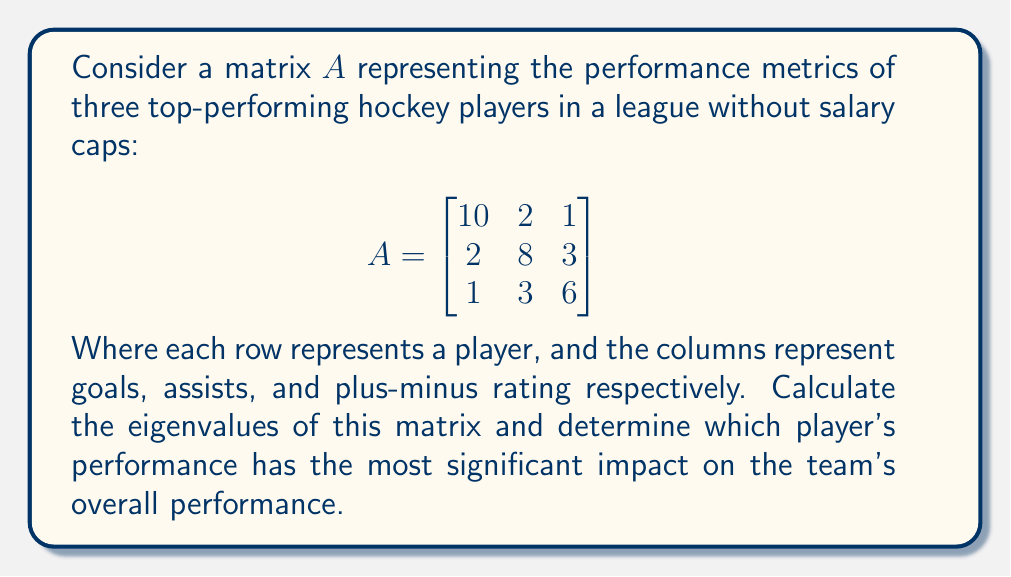What is the answer to this math problem? To find the eigenvalues of matrix $A$, we need to solve the characteristic equation:

$\det(A - \lambda I) = 0$

1) First, let's set up the matrix $A - \lambda I$:

$$A - \lambda I = \begin{bmatrix}
10-\lambda & 2 & 1 \\
2 & 8-\lambda & 3 \\
1 & 3 & 6-\lambda
\end{bmatrix}$$

2) Now, we calculate the determinant:

$\det(A - \lambda I) = (10-\lambda)[(8-\lambda)(6-\lambda) - 9] - 2[2(6-\lambda) - 3] + 1[2(3) - (8-\lambda)]$

3) Expanding this:

$\det(A - \lambda I) = (10-\lambda)(48-14\lambda+\lambda^2-9) - 2(12-2\lambda-3) + (6-8+\lambda)$
$= (10-\lambda)(39-14\lambda+\lambda^2) - 2(9-2\lambda) + (\lambda-2)$
$= 390 - 140\lambda + 10\lambda^2 - 39\lambda + 14\lambda^2 - \lambda^3 - 18 + 4\lambda + \lambda - 2$
$= -\lambda^3 + 24\lambda^2 - 175\lambda + 370$

4) The characteristic equation is:

$-\lambda^3 + 24\lambda^2 - 175\lambda + 370 = 0$

5) Solving this equation (using a computer algebra system or numerical methods), we get the eigenvalues:

$\lambda_1 \approx 12.5735$
$\lambda_2 \approx 8.2132$
$\lambda_3 \approx 3.2133$

6) The largest eigenvalue, $\lambda_1 \approx 12.5735$, corresponds to the most significant impact on the team's overall performance. This eigenvalue is closest to the first diagonal element (10) in the original matrix, which represents the first player's goal-scoring ability.

Therefore, in this meritocratic system without salary caps, the first player (represented by the first row of the matrix) has the most significant impact on the team's overall performance.
Answer: Eigenvalues: 12.5735, 8.2132, 3.2133. First player has the most impact. 